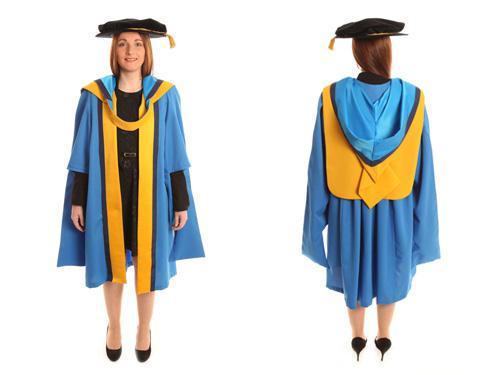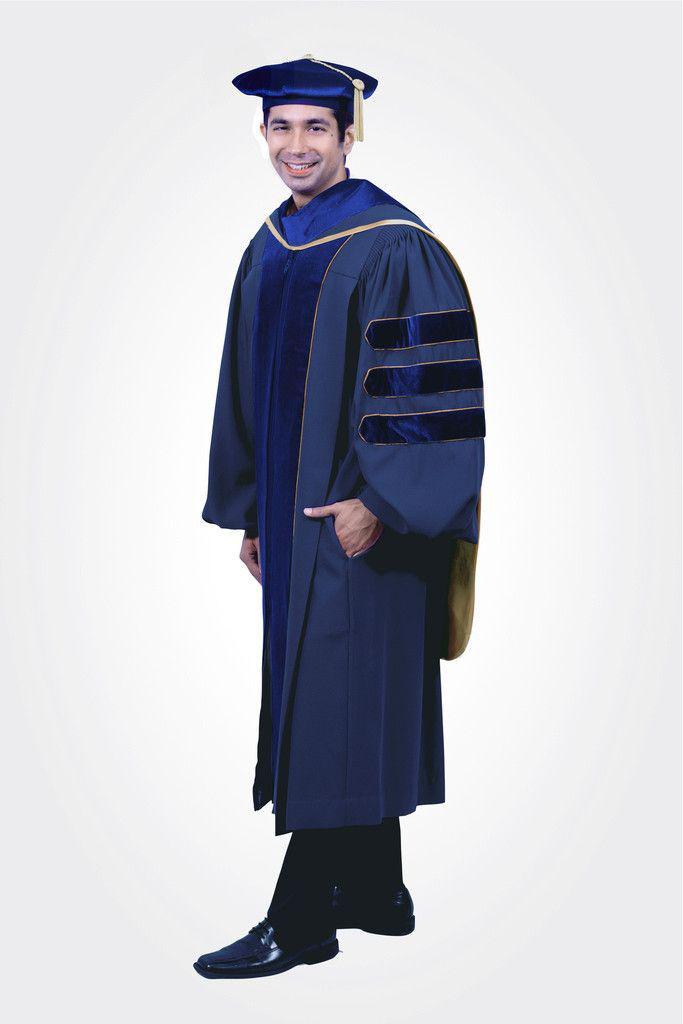The first image is the image on the left, the second image is the image on the right. Analyze the images presented: Is the assertion "One person is wearing red." valid? Answer yes or no. No. 